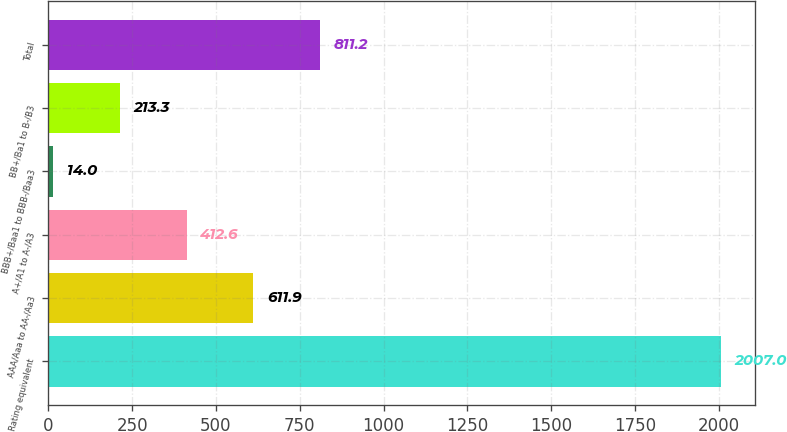<chart> <loc_0><loc_0><loc_500><loc_500><bar_chart><fcel>Rating equivalent<fcel>AAA/Aaa to AA-/Aa3<fcel>A+/A1 to A-/A3<fcel>BBB+/Baa1 to BBB-/Baa3<fcel>BB+/Ba1 to B-/B3<fcel>Total<nl><fcel>2007<fcel>611.9<fcel>412.6<fcel>14<fcel>213.3<fcel>811.2<nl></chart> 